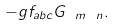<formula> <loc_0><loc_0><loc_500><loc_500>- g f _ { a b c } G _ { \ m \ n } .</formula> 